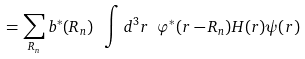<formula> <loc_0><loc_0><loc_500><loc_500>= \sum _ { R _ { n } } b ^ { * } ( { R _ { n } } ) \ \int d ^ { 3 } r \ \varphi ^ { * } ( { r - R _ { n } } ) H ( { r } ) \psi ( { r } )</formula> 